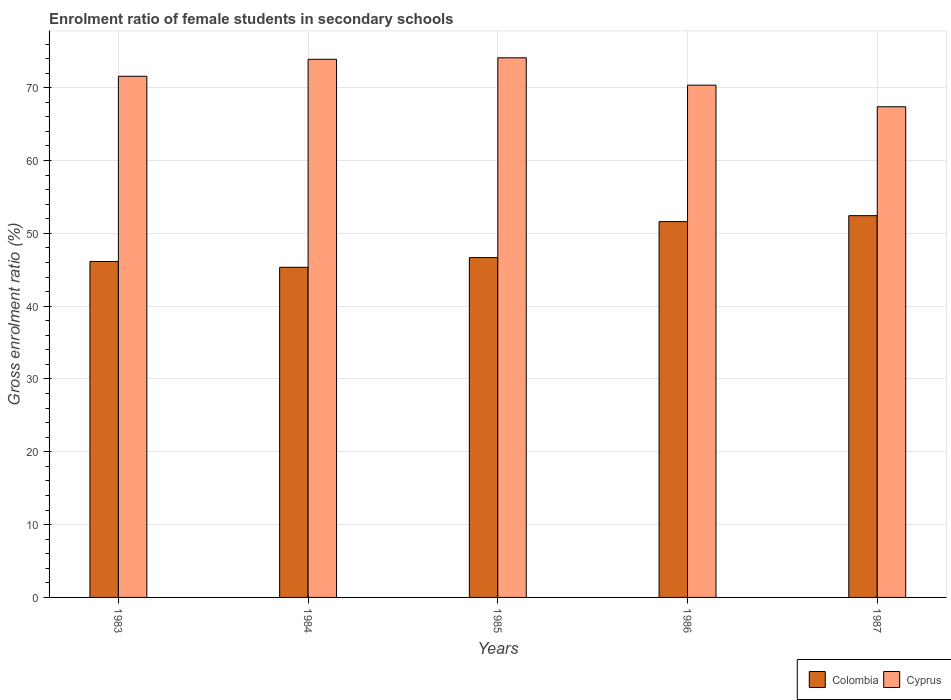How many different coloured bars are there?
Provide a succinct answer. 2. How many groups of bars are there?
Your answer should be very brief. 5. Are the number of bars on each tick of the X-axis equal?
Provide a succinct answer. Yes. What is the enrolment ratio of female students in secondary schools in Colombia in 1983?
Ensure brevity in your answer.  46.13. Across all years, what is the maximum enrolment ratio of female students in secondary schools in Cyprus?
Provide a succinct answer. 74.11. Across all years, what is the minimum enrolment ratio of female students in secondary schools in Colombia?
Offer a terse response. 45.34. In which year was the enrolment ratio of female students in secondary schools in Cyprus maximum?
Make the answer very short. 1985. What is the total enrolment ratio of female students in secondary schools in Cyprus in the graph?
Your response must be concise. 357.31. What is the difference between the enrolment ratio of female students in secondary schools in Colombia in 1983 and that in 1986?
Make the answer very short. -5.48. What is the difference between the enrolment ratio of female students in secondary schools in Colombia in 1987 and the enrolment ratio of female students in secondary schools in Cyprus in 1984?
Offer a terse response. -21.48. What is the average enrolment ratio of female students in secondary schools in Colombia per year?
Provide a succinct answer. 48.44. In the year 1985, what is the difference between the enrolment ratio of female students in secondary schools in Colombia and enrolment ratio of female students in secondary schools in Cyprus?
Keep it short and to the point. -27.43. What is the ratio of the enrolment ratio of female students in secondary schools in Colombia in 1985 to that in 1987?
Your answer should be compact. 0.89. Is the enrolment ratio of female students in secondary schools in Colombia in 1984 less than that in 1986?
Make the answer very short. Yes. Is the difference between the enrolment ratio of female students in secondary schools in Colombia in 1986 and 1987 greater than the difference between the enrolment ratio of female students in secondary schools in Cyprus in 1986 and 1987?
Offer a terse response. No. What is the difference between the highest and the second highest enrolment ratio of female students in secondary schools in Colombia?
Ensure brevity in your answer.  0.82. What is the difference between the highest and the lowest enrolment ratio of female students in secondary schools in Cyprus?
Give a very brief answer. 6.72. What does the 2nd bar from the left in 1983 represents?
Provide a short and direct response. Cyprus. What does the 2nd bar from the right in 1987 represents?
Your answer should be compact. Colombia. How many bars are there?
Your answer should be very brief. 10. Are all the bars in the graph horizontal?
Provide a succinct answer. No. Does the graph contain grids?
Make the answer very short. Yes. Where does the legend appear in the graph?
Give a very brief answer. Bottom right. What is the title of the graph?
Provide a short and direct response. Enrolment ratio of female students in secondary schools. Does "Mongolia" appear as one of the legend labels in the graph?
Your answer should be very brief. No. What is the label or title of the X-axis?
Offer a terse response. Years. What is the label or title of the Y-axis?
Your response must be concise. Gross enrolment ratio (%). What is the Gross enrolment ratio (%) in Colombia in 1983?
Keep it short and to the point. 46.13. What is the Gross enrolment ratio (%) of Cyprus in 1983?
Keep it short and to the point. 71.57. What is the Gross enrolment ratio (%) in Colombia in 1984?
Your response must be concise. 45.34. What is the Gross enrolment ratio (%) of Cyprus in 1984?
Offer a very short reply. 73.9. What is the Gross enrolment ratio (%) of Colombia in 1985?
Provide a succinct answer. 46.67. What is the Gross enrolment ratio (%) in Cyprus in 1985?
Ensure brevity in your answer.  74.11. What is the Gross enrolment ratio (%) of Colombia in 1986?
Offer a terse response. 51.61. What is the Gross enrolment ratio (%) of Cyprus in 1986?
Your answer should be compact. 70.35. What is the Gross enrolment ratio (%) of Colombia in 1987?
Your answer should be compact. 52.43. What is the Gross enrolment ratio (%) of Cyprus in 1987?
Make the answer very short. 67.38. Across all years, what is the maximum Gross enrolment ratio (%) in Colombia?
Offer a terse response. 52.43. Across all years, what is the maximum Gross enrolment ratio (%) in Cyprus?
Your answer should be very brief. 74.11. Across all years, what is the minimum Gross enrolment ratio (%) in Colombia?
Provide a succinct answer. 45.34. Across all years, what is the minimum Gross enrolment ratio (%) in Cyprus?
Your answer should be compact. 67.38. What is the total Gross enrolment ratio (%) of Colombia in the graph?
Make the answer very short. 242.18. What is the total Gross enrolment ratio (%) in Cyprus in the graph?
Provide a short and direct response. 357.31. What is the difference between the Gross enrolment ratio (%) of Colombia in 1983 and that in 1984?
Offer a terse response. 0.8. What is the difference between the Gross enrolment ratio (%) of Cyprus in 1983 and that in 1984?
Your response must be concise. -2.33. What is the difference between the Gross enrolment ratio (%) of Colombia in 1983 and that in 1985?
Keep it short and to the point. -0.54. What is the difference between the Gross enrolment ratio (%) of Cyprus in 1983 and that in 1985?
Provide a succinct answer. -2.53. What is the difference between the Gross enrolment ratio (%) of Colombia in 1983 and that in 1986?
Keep it short and to the point. -5.48. What is the difference between the Gross enrolment ratio (%) of Cyprus in 1983 and that in 1986?
Your response must be concise. 1.22. What is the difference between the Gross enrolment ratio (%) in Colombia in 1983 and that in 1987?
Make the answer very short. -6.29. What is the difference between the Gross enrolment ratio (%) in Cyprus in 1983 and that in 1987?
Your answer should be very brief. 4.19. What is the difference between the Gross enrolment ratio (%) of Colombia in 1984 and that in 1985?
Your response must be concise. -1.34. What is the difference between the Gross enrolment ratio (%) in Cyprus in 1984 and that in 1985?
Offer a terse response. -0.2. What is the difference between the Gross enrolment ratio (%) in Colombia in 1984 and that in 1986?
Provide a succinct answer. -6.28. What is the difference between the Gross enrolment ratio (%) in Cyprus in 1984 and that in 1986?
Provide a succinct answer. 3.55. What is the difference between the Gross enrolment ratio (%) of Colombia in 1984 and that in 1987?
Your answer should be compact. -7.09. What is the difference between the Gross enrolment ratio (%) in Cyprus in 1984 and that in 1987?
Offer a very short reply. 6.52. What is the difference between the Gross enrolment ratio (%) of Colombia in 1985 and that in 1986?
Provide a succinct answer. -4.94. What is the difference between the Gross enrolment ratio (%) in Cyprus in 1985 and that in 1986?
Provide a short and direct response. 3.76. What is the difference between the Gross enrolment ratio (%) of Colombia in 1985 and that in 1987?
Provide a succinct answer. -5.75. What is the difference between the Gross enrolment ratio (%) in Cyprus in 1985 and that in 1987?
Your answer should be very brief. 6.72. What is the difference between the Gross enrolment ratio (%) of Colombia in 1986 and that in 1987?
Your response must be concise. -0.82. What is the difference between the Gross enrolment ratio (%) in Cyprus in 1986 and that in 1987?
Offer a very short reply. 2.97. What is the difference between the Gross enrolment ratio (%) of Colombia in 1983 and the Gross enrolment ratio (%) of Cyprus in 1984?
Provide a short and direct response. -27.77. What is the difference between the Gross enrolment ratio (%) in Colombia in 1983 and the Gross enrolment ratio (%) in Cyprus in 1985?
Your answer should be very brief. -27.97. What is the difference between the Gross enrolment ratio (%) of Colombia in 1983 and the Gross enrolment ratio (%) of Cyprus in 1986?
Your answer should be very brief. -24.21. What is the difference between the Gross enrolment ratio (%) of Colombia in 1983 and the Gross enrolment ratio (%) of Cyprus in 1987?
Offer a very short reply. -21.25. What is the difference between the Gross enrolment ratio (%) in Colombia in 1984 and the Gross enrolment ratio (%) in Cyprus in 1985?
Give a very brief answer. -28.77. What is the difference between the Gross enrolment ratio (%) in Colombia in 1984 and the Gross enrolment ratio (%) in Cyprus in 1986?
Provide a succinct answer. -25.01. What is the difference between the Gross enrolment ratio (%) in Colombia in 1984 and the Gross enrolment ratio (%) in Cyprus in 1987?
Ensure brevity in your answer.  -22.05. What is the difference between the Gross enrolment ratio (%) in Colombia in 1985 and the Gross enrolment ratio (%) in Cyprus in 1986?
Ensure brevity in your answer.  -23.68. What is the difference between the Gross enrolment ratio (%) of Colombia in 1985 and the Gross enrolment ratio (%) of Cyprus in 1987?
Keep it short and to the point. -20.71. What is the difference between the Gross enrolment ratio (%) of Colombia in 1986 and the Gross enrolment ratio (%) of Cyprus in 1987?
Provide a succinct answer. -15.77. What is the average Gross enrolment ratio (%) of Colombia per year?
Keep it short and to the point. 48.44. What is the average Gross enrolment ratio (%) in Cyprus per year?
Offer a terse response. 71.46. In the year 1983, what is the difference between the Gross enrolment ratio (%) of Colombia and Gross enrolment ratio (%) of Cyprus?
Your response must be concise. -25.44. In the year 1984, what is the difference between the Gross enrolment ratio (%) of Colombia and Gross enrolment ratio (%) of Cyprus?
Provide a succinct answer. -28.57. In the year 1985, what is the difference between the Gross enrolment ratio (%) of Colombia and Gross enrolment ratio (%) of Cyprus?
Keep it short and to the point. -27.43. In the year 1986, what is the difference between the Gross enrolment ratio (%) in Colombia and Gross enrolment ratio (%) in Cyprus?
Your answer should be compact. -18.74. In the year 1987, what is the difference between the Gross enrolment ratio (%) of Colombia and Gross enrolment ratio (%) of Cyprus?
Offer a terse response. -14.96. What is the ratio of the Gross enrolment ratio (%) of Colombia in 1983 to that in 1984?
Provide a succinct answer. 1.02. What is the ratio of the Gross enrolment ratio (%) of Cyprus in 1983 to that in 1984?
Provide a short and direct response. 0.97. What is the ratio of the Gross enrolment ratio (%) in Cyprus in 1983 to that in 1985?
Keep it short and to the point. 0.97. What is the ratio of the Gross enrolment ratio (%) of Colombia in 1983 to that in 1986?
Your answer should be compact. 0.89. What is the ratio of the Gross enrolment ratio (%) in Cyprus in 1983 to that in 1986?
Offer a terse response. 1.02. What is the ratio of the Gross enrolment ratio (%) in Cyprus in 1983 to that in 1987?
Offer a terse response. 1.06. What is the ratio of the Gross enrolment ratio (%) in Colombia in 1984 to that in 1985?
Ensure brevity in your answer.  0.97. What is the ratio of the Gross enrolment ratio (%) of Cyprus in 1984 to that in 1985?
Provide a short and direct response. 1. What is the ratio of the Gross enrolment ratio (%) in Colombia in 1984 to that in 1986?
Your answer should be very brief. 0.88. What is the ratio of the Gross enrolment ratio (%) in Cyprus in 1984 to that in 1986?
Offer a very short reply. 1.05. What is the ratio of the Gross enrolment ratio (%) of Colombia in 1984 to that in 1987?
Offer a very short reply. 0.86. What is the ratio of the Gross enrolment ratio (%) in Cyprus in 1984 to that in 1987?
Provide a short and direct response. 1.1. What is the ratio of the Gross enrolment ratio (%) of Colombia in 1985 to that in 1986?
Offer a very short reply. 0.9. What is the ratio of the Gross enrolment ratio (%) in Cyprus in 1985 to that in 1986?
Provide a succinct answer. 1.05. What is the ratio of the Gross enrolment ratio (%) in Colombia in 1985 to that in 1987?
Your answer should be very brief. 0.89. What is the ratio of the Gross enrolment ratio (%) of Cyprus in 1985 to that in 1987?
Give a very brief answer. 1.1. What is the ratio of the Gross enrolment ratio (%) of Colombia in 1986 to that in 1987?
Your answer should be very brief. 0.98. What is the ratio of the Gross enrolment ratio (%) in Cyprus in 1986 to that in 1987?
Make the answer very short. 1.04. What is the difference between the highest and the second highest Gross enrolment ratio (%) of Colombia?
Provide a short and direct response. 0.82. What is the difference between the highest and the second highest Gross enrolment ratio (%) of Cyprus?
Keep it short and to the point. 0.2. What is the difference between the highest and the lowest Gross enrolment ratio (%) in Colombia?
Your answer should be very brief. 7.09. What is the difference between the highest and the lowest Gross enrolment ratio (%) of Cyprus?
Provide a short and direct response. 6.72. 